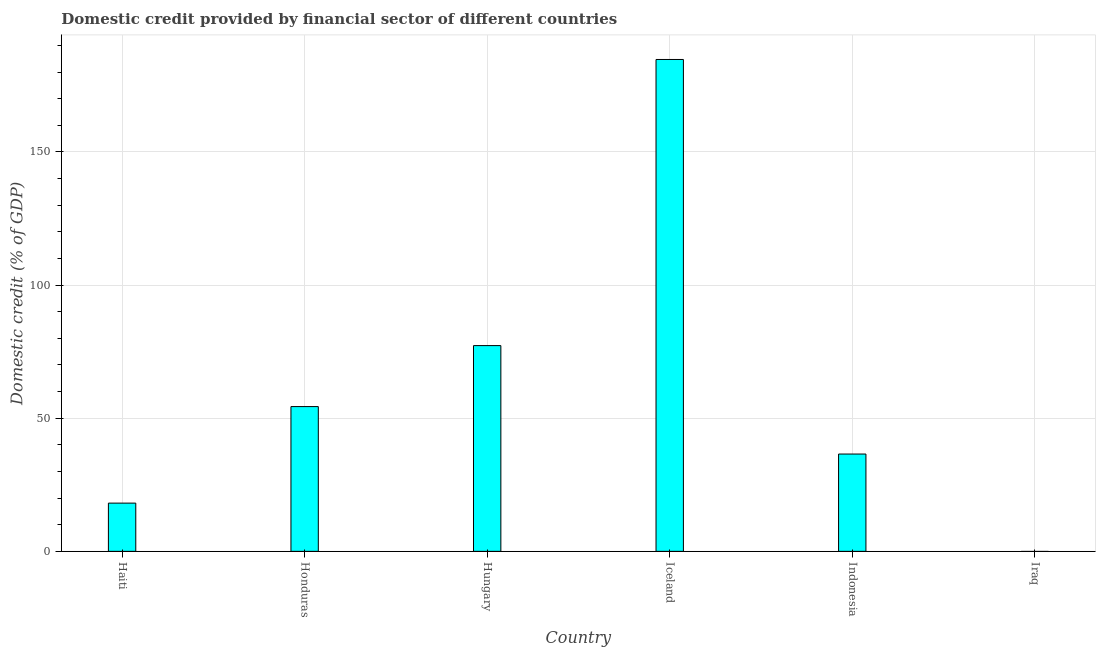Does the graph contain any zero values?
Provide a short and direct response. Yes. What is the title of the graph?
Offer a very short reply. Domestic credit provided by financial sector of different countries. What is the label or title of the Y-axis?
Your answer should be compact. Domestic credit (% of GDP). What is the domestic credit provided by financial sector in Hungary?
Provide a succinct answer. 77.27. Across all countries, what is the maximum domestic credit provided by financial sector?
Keep it short and to the point. 184.73. Across all countries, what is the minimum domestic credit provided by financial sector?
Give a very brief answer. 0. What is the sum of the domestic credit provided by financial sector?
Your answer should be very brief. 371.04. What is the difference between the domestic credit provided by financial sector in Iceland and Indonesia?
Offer a very short reply. 148.18. What is the average domestic credit provided by financial sector per country?
Ensure brevity in your answer.  61.84. What is the median domestic credit provided by financial sector?
Provide a succinct answer. 45.46. In how many countries, is the domestic credit provided by financial sector greater than 60 %?
Provide a short and direct response. 2. What is the ratio of the domestic credit provided by financial sector in Honduras to that in Iceland?
Provide a succinct answer. 0.29. Is the difference between the domestic credit provided by financial sector in Honduras and Iceland greater than the difference between any two countries?
Your answer should be compact. No. What is the difference between the highest and the second highest domestic credit provided by financial sector?
Your answer should be compact. 107.46. What is the difference between the highest and the lowest domestic credit provided by financial sector?
Ensure brevity in your answer.  184.73. In how many countries, is the domestic credit provided by financial sector greater than the average domestic credit provided by financial sector taken over all countries?
Offer a terse response. 2. What is the difference between two consecutive major ticks on the Y-axis?
Your response must be concise. 50. Are the values on the major ticks of Y-axis written in scientific E-notation?
Keep it short and to the point. No. What is the Domestic credit (% of GDP) of Haiti?
Offer a terse response. 18.12. What is the Domestic credit (% of GDP) of Honduras?
Your response must be concise. 54.37. What is the Domestic credit (% of GDP) of Hungary?
Give a very brief answer. 77.27. What is the Domestic credit (% of GDP) of Iceland?
Your answer should be compact. 184.73. What is the Domestic credit (% of GDP) of Indonesia?
Your response must be concise. 36.55. What is the Domestic credit (% of GDP) in Iraq?
Offer a terse response. 0. What is the difference between the Domestic credit (% of GDP) in Haiti and Honduras?
Offer a very short reply. -36.26. What is the difference between the Domestic credit (% of GDP) in Haiti and Hungary?
Keep it short and to the point. -59.16. What is the difference between the Domestic credit (% of GDP) in Haiti and Iceland?
Keep it short and to the point. -166.62. What is the difference between the Domestic credit (% of GDP) in Haiti and Indonesia?
Make the answer very short. -18.43. What is the difference between the Domestic credit (% of GDP) in Honduras and Hungary?
Your answer should be very brief. -22.9. What is the difference between the Domestic credit (% of GDP) in Honduras and Iceland?
Make the answer very short. -130.36. What is the difference between the Domestic credit (% of GDP) in Honduras and Indonesia?
Your response must be concise. 17.82. What is the difference between the Domestic credit (% of GDP) in Hungary and Iceland?
Offer a terse response. -107.46. What is the difference between the Domestic credit (% of GDP) in Hungary and Indonesia?
Offer a very short reply. 40.72. What is the difference between the Domestic credit (% of GDP) in Iceland and Indonesia?
Provide a succinct answer. 148.18. What is the ratio of the Domestic credit (% of GDP) in Haiti to that in Honduras?
Provide a short and direct response. 0.33. What is the ratio of the Domestic credit (% of GDP) in Haiti to that in Hungary?
Offer a terse response. 0.23. What is the ratio of the Domestic credit (% of GDP) in Haiti to that in Iceland?
Provide a succinct answer. 0.1. What is the ratio of the Domestic credit (% of GDP) in Haiti to that in Indonesia?
Your answer should be compact. 0.5. What is the ratio of the Domestic credit (% of GDP) in Honduras to that in Hungary?
Ensure brevity in your answer.  0.7. What is the ratio of the Domestic credit (% of GDP) in Honduras to that in Iceland?
Your answer should be very brief. 0.29. What is the ratio of the Domestic credit (% of GDP) in Honduras to that in Indonesia?
Offer a terse response. 1.49. What is the ratio of the Domestic credit (% of GDP) in Hungary to that in Iceland?
Offer a terse response. 0.42. What is the ratio of the Domestic credit (% of GDP) in Hungary to that in Indonesia?
Make the answer very short. 2.11. What is the ratio of the Domestic credit (% of GDP) in Iceland to that in Indonesia?
Provide a short and direct response. 5.05. 